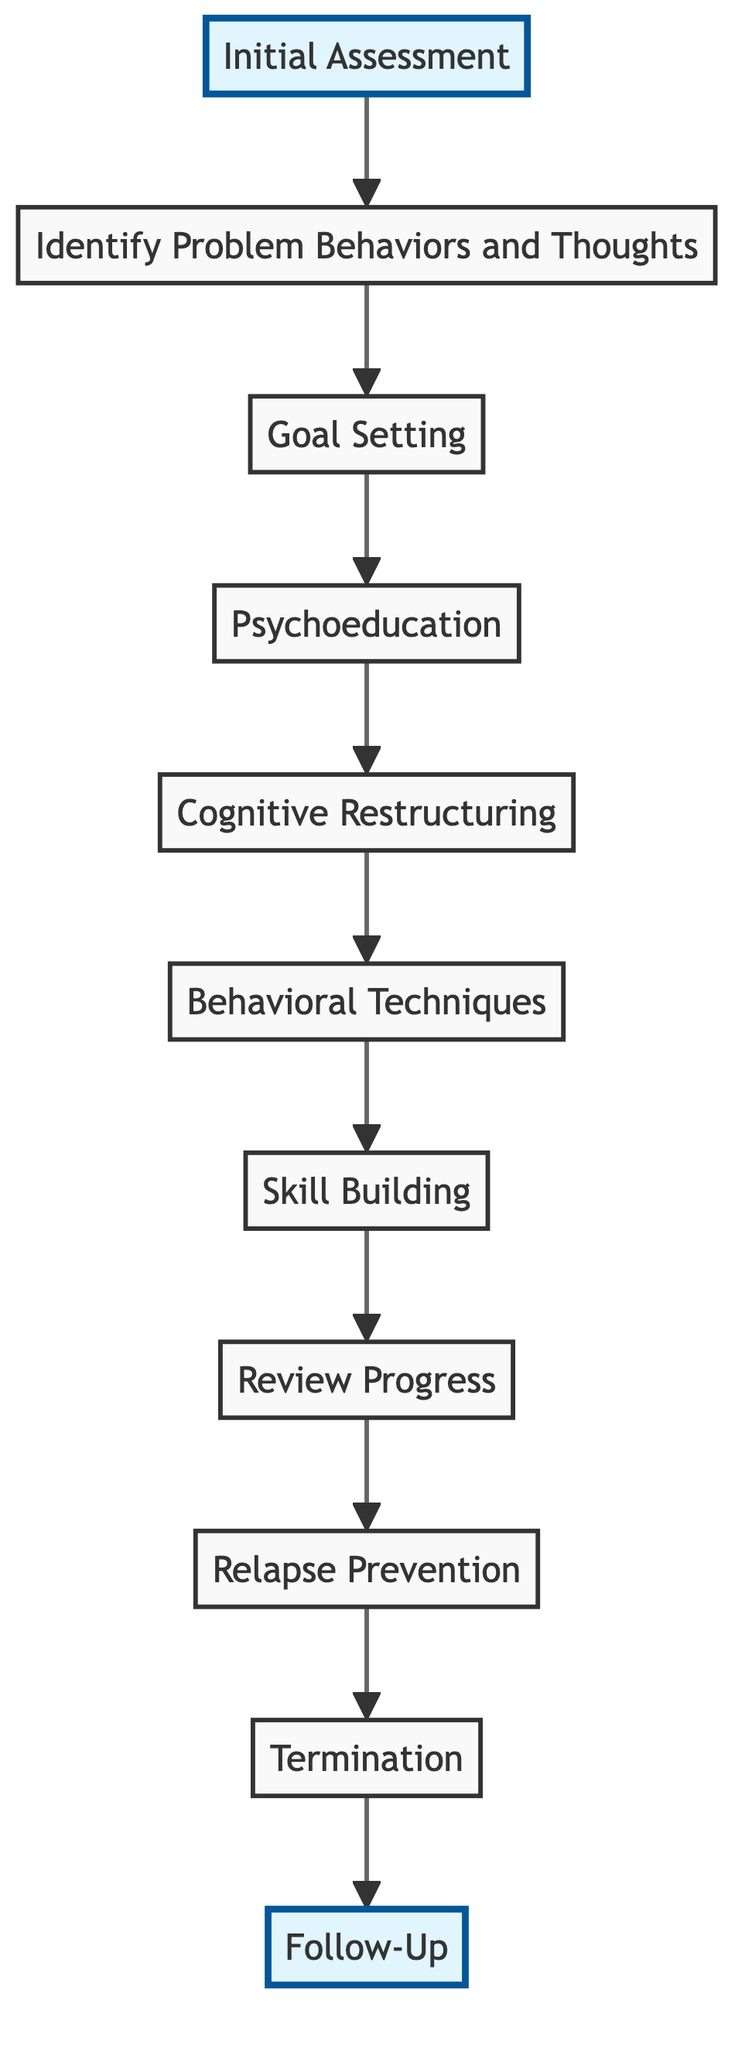What is the first stage of CBT in this diagram? The first stage depicted in the diagram is labeled "Initial Assessment", which is shown at the top of the directed graph as the starting point.
Answer: Initial Assessment How many nodes are there in the diagram? The diagram lists a total of 11 distinct nodes, each representing a different stage or aspect of the CBT process.
Answer: 11 Which node comes immediately after "Skill Building"? According to the directional edges in the diagram, "Review Progress" is the node that follows "Skill Building", indicated by the arrow leading from "Skill Building" to "Review Progress".
Answer: Review Progress What is the last stage before the Follow-Up? The stage preceding "Follow-Up" in the diagram is "Termination", as represented by the edge connecting "Termination" to "Follow-Up".
Answer: Termination Describe the relationship between "Cognitive Restructuring" and "Behavioral Techniques." The diagram shows a direct edge between "Cognitive Restructuring" and "Behavioral Techniques," indicating that "Cognitive Restructuring" leads into "Behavioral Techniques" as a subsequent step in the CBT model.
Answer: Direct connection What is the total number of edges in the diagram? There are a total of 10 edges depicted in the directed graph, each representing a connection or progression from one stage to the next in the CBT process.
Answer: 10 Which node follows "Review Progress"? The node that follows "Review Progress" according to the directionality of the edges in the diagram is "Relapse Prevention", established by the arrow leading from "Review Progress" to "Relapse Prevention".
Answer: Relapse Prevention Does the graph contain any loops? Upon examining the connections in the directed graph, it is evident that there are no loops, as each edge creates a one-way progression towards the termination and follow-up stages without returning to any previous nodes.
Answer: No What two nodes are directly connected to "Psychoeducation"? The edge from "Goal Setting" leads into "Psychoeducation" and then directly connects to "Cognitive Restructuring," demonstrating that "Goal Setting" moves to "Psychoeducation," which in turn progresses to "Cognitive Restructuring."
Answer: Goal Setting, Cognitive Restructuring 